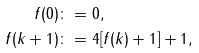<formula> <loc_0><loc_0><loc_500><loc_500>f ( 0 ) & \colon = 0 , \\ f ( k + 1 ) & \colon = 4 [ f ( k ) + 1 ] + 1 ,</formula> 